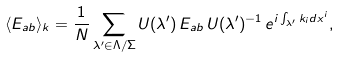Convert formula to latex. <formula><loc_0><loc_0><loc_500><loc_500>\langle E _ { a b } \rangle _ { k } = \frac { 1 } { N } \sum _ { \lambda ^ { \prime } \in \Lambda / \Sigma } U ( \lambda ^ { \prime } ) \, E _ { a b } \, U ( \lambda ^ { \prime } ) ^ { - 1 } \, e ^ { i \int _ { \lambda ^ { \prime } } k _ { i } d x ^ { i } } ,</formula> 